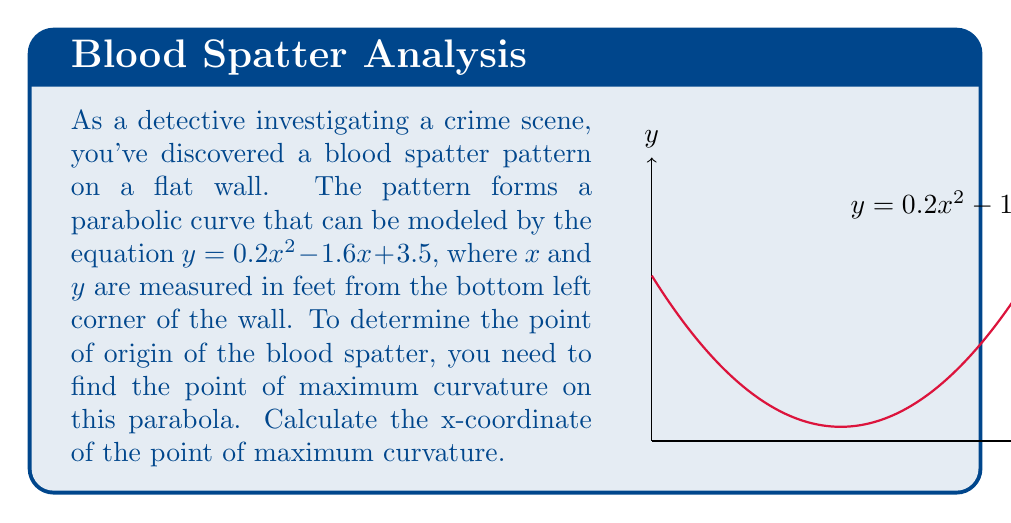What is the answer to this math problem? To find the point of maximum curvature, we'll follow these steps:

1) The curvature of a function $y=f(x)$ is given by the formula:

   $$\kappa = \frac{|f''(x)|}{(1+(f'(x))^2)^{3/2}}$$

2) First, let's find $f'(x)$ and $f''(x)$:
   
   $f'(x) = 0.4x - 1.6$
   $f''(x) = 0.4$

3) Since $f''(x)$ is constant, the numerator of the curvature formula will be constant. The maximum curvature will occur where the denominator is at its minimum.

4) The denominator is $(1+(f'(x))^2)^{3/2}$. To minimize this, we need to minimize $f'(x)^2$.

5) $f'(x)^2 = (0.4x - 1.6)^2 = 0.16x^2 - 1.28x + 2.56$

6) To find the minimum of this quadratic function, we find where its derivative equals zero:
   
   $\frac{d}{dx}(f'(x)^2) = 0.32x - 1.28 = 0$

7) Solving this:
   
   $0.32x = 1.28$
   $x = 4$

8) Therefore, the point of maximum curvature occurs at $x = 4$ feet from the left edge of the wall.
Answer: 4 feet 